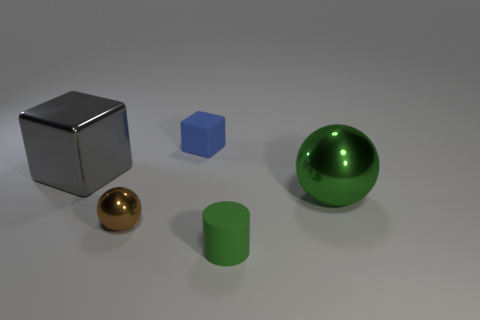Are there an equal number of gray cubes that are on the right side of the small cylinder and large green shiny balls?
Ensure brevity in your answer.  No. There is a large metallic sphere; does it have the same color as the rubber object in front of the big green object?
Your answer should be very brief. Yes. What color is the small object that is both to the left of the green cylinder and in front of the large green metallic thing?
Offer a terse response. Brown. There is a large thing on the right side of the gray metal thing; what number of objects are to the left of it?
Offer a very short reply. 4. Are there any green metal objects of the same shape as the tiny green rubber object?
Give a very brief answer. No. There is a big metal object that is on the right side of the blue thing; is its shape the same as the large gray metallic thing that is on the left side of the matte cylinder?
Your response must be concise. No. What number of things are small blue rubber objects or large cylinders?
Offer a very short reply. 1. There is a blue object that is the same shape as the gray metallic thing; what is its size?
Your answer should be compact. Small. Are there more blue matte cubes in front of the green metal thing than small metal things?
Provide a short and direct response. No. Is the tiny green object made of the same material as the small blue object?
Provide a succinct answer. Yes. 